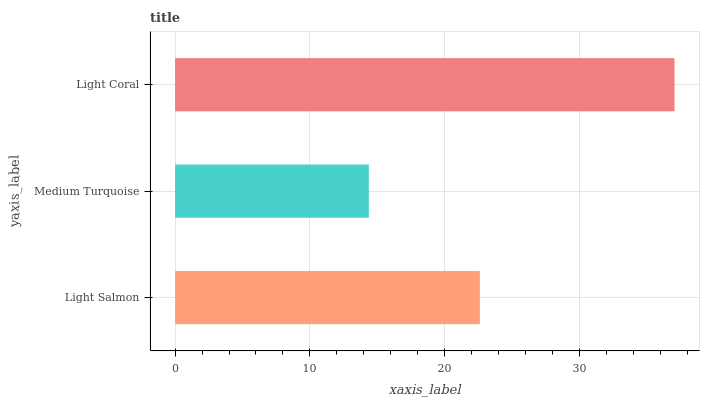Is Medium Turquoise the minimum?
Answer yes or no. Yes. Is Light Coral the maximum?
Answer yes or no. Yes. Is Light Coral the minimum?
Answer yes or no. No. Is Medium Turquoise the maximum?
Answer yes or no. No. Is Light Coral greater than Medium Turquoise?
Answer yes or no. Yes. Is Medium Turquoise less than Light Coral?
Answer yes or no. Yes. Is Medium Turquoise greater than Light Coral?
Answer yes or no. No. Is Light Coral less than Medium Turquoise?
Answer yes or no. No. Is Light Salmon the high median?
Answer yes or no. Yes. Is Light Salmon the low median?
Answer yes or no. Yes. Is Medium Turquoise the high median?
Answer yes or no. No. Is Light Coral the low median?
Answer yes or no. No. 